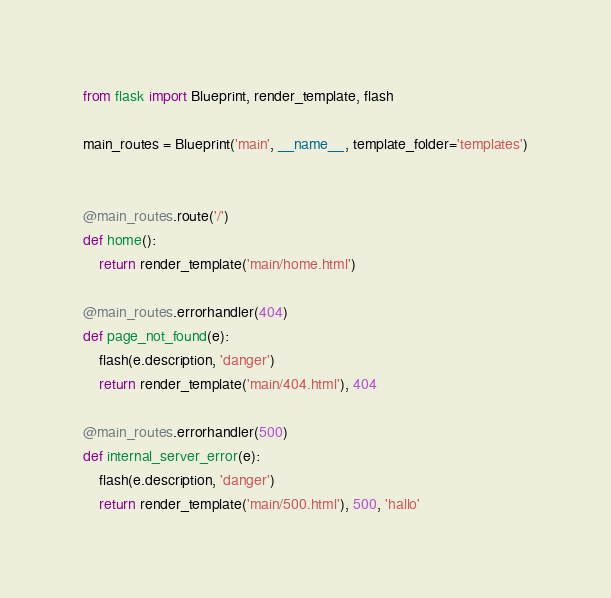Convert code to text. <code><loc_0><loc_0><loc_500><loc_500><_Python_>from flask import Blueprint, render_template, flash

main_routes = Blueprint('main', __name__, template_folder='templates')


@main_routes.route('/')
def home():
    return render_template('main/home.html')

@main_routes.errorhandler(404)
def page_not_found(e):
    flash(e.description, 'danger')
    return render_template('main/404.html'), 404

@main_routes.errorhandler(500)
def internal_server_error(e):
    flash(e.description, 'danger')
    return render_template('main/500.html'), 500, 'hallo'
</code> 